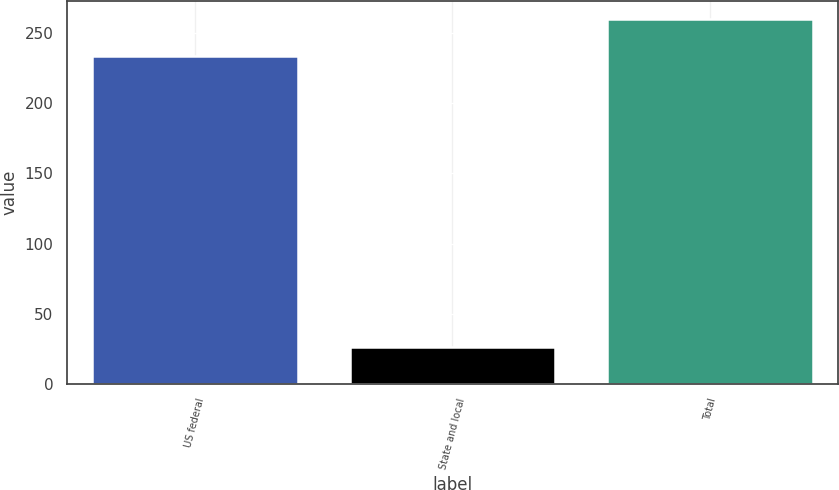<chart> <loc_0><loc_0><loc_500><loc_500><bar_chart><fcel>US federal<fcel>State and local<fcel>Total<nl><fcel>234<fcel>26<fcel>260<nl></chart> 